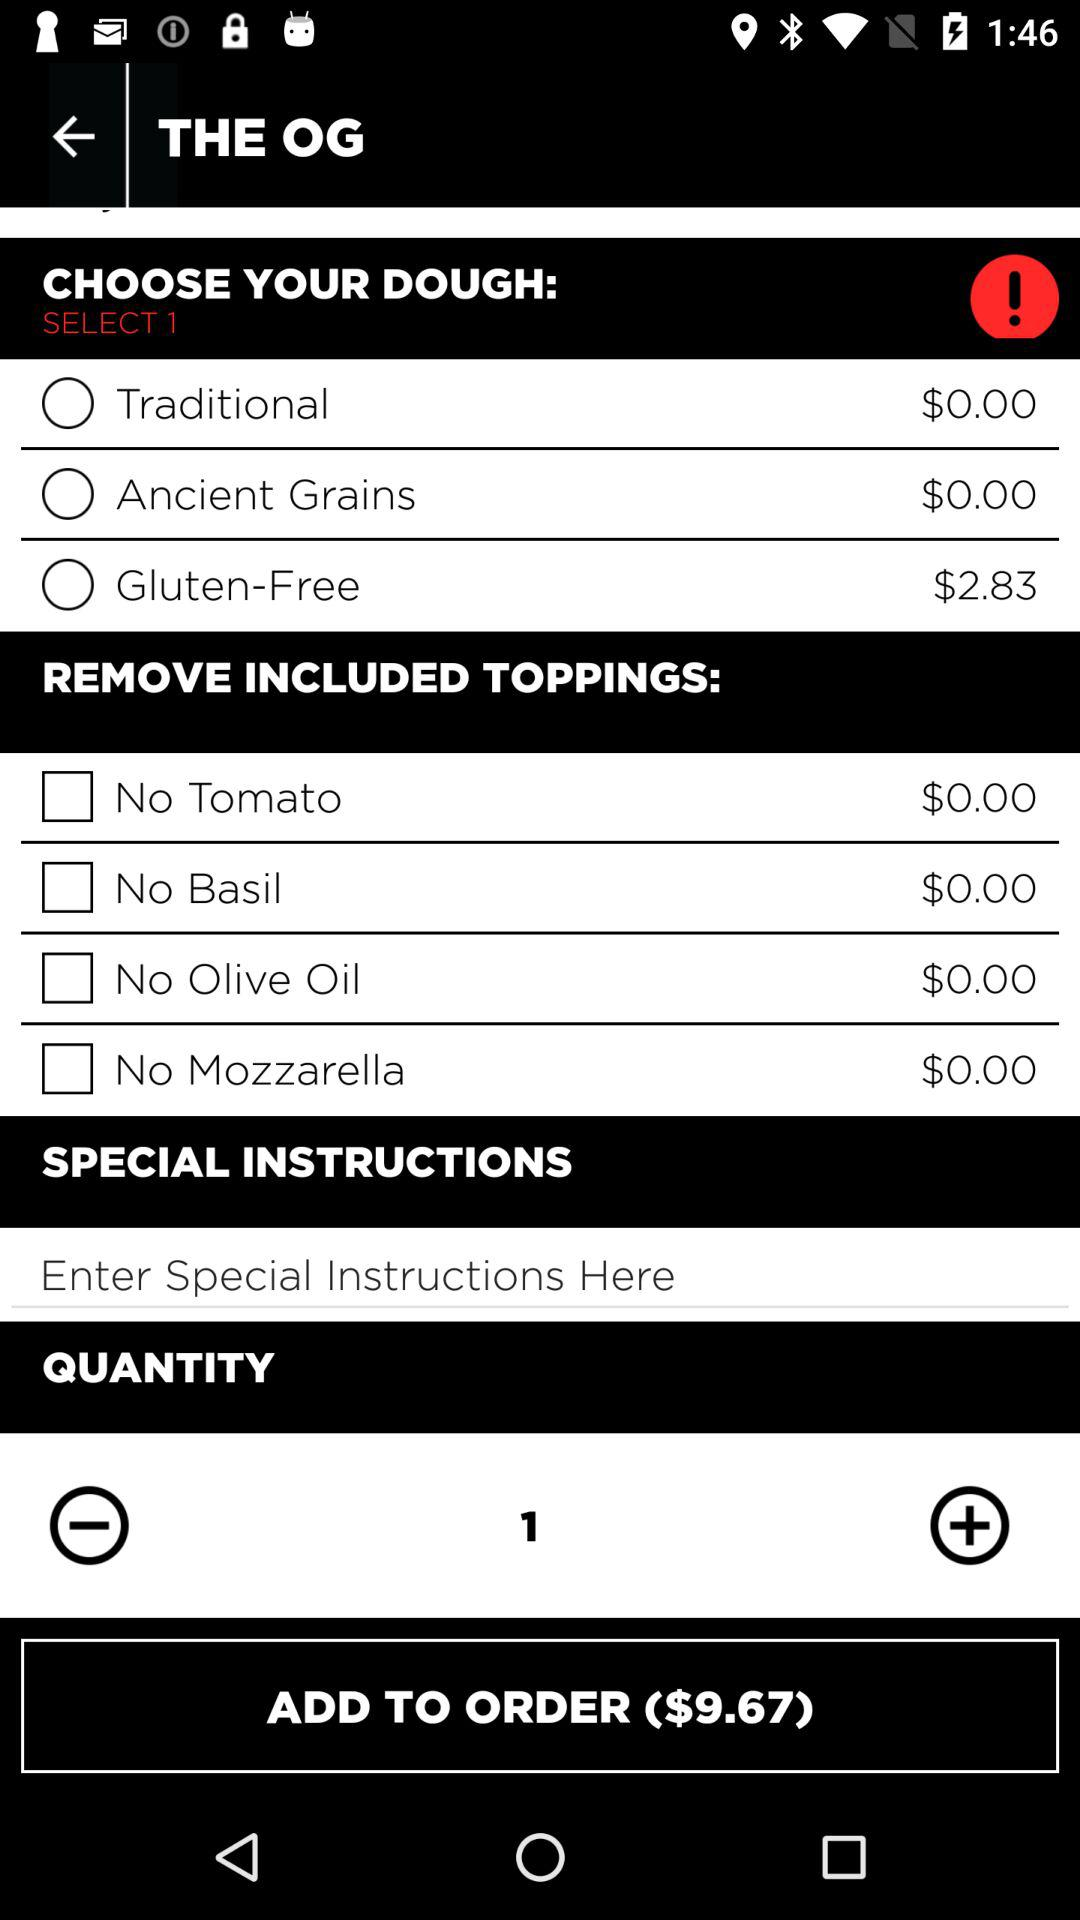What is the application name?
When the provided information is insufficient, respond with <no answer>. <no answer> 